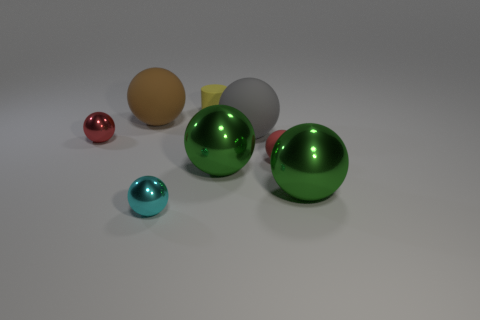There is a big sphere that is left of the gray rubber thing and in front of the large brown thing; what is its material? metal 